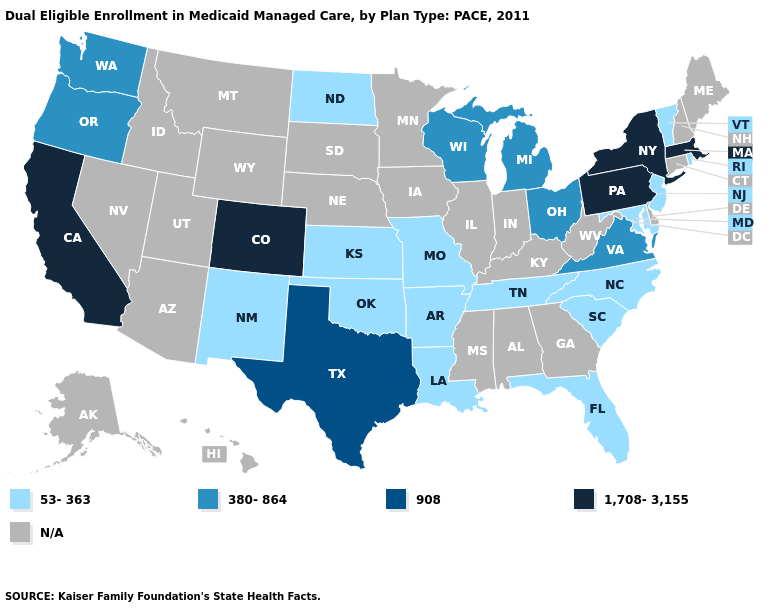Name the states that have a value in the range 908?
Be succinct. Texas. What is the value of Nevada?
Answer briefly. N/A. Name the states that have a value in the range 53-363?
Answer briefly. Arkansas, Florida, Kansas, Louisiana, Maryland, Missouri, New Jersey, New Mexico, North Carolina, North Dakota, Oklahoma, Rhode Island, South Carolina, Tennessee, Vermont. Does New Jersey have the highest value in the Northeast?
Keep it brief. No. What is the value of Michigan?
Concise answer only. 380-864. Which states have the highest value in the USA?
Concise answer only. California, Colorado, Massachusetts, New York, Pennsylvania. Name the states that have a value in the range 380-864?
Concise answer only. Michigan, Ohio, Oregon, Virginia, Washington, Wisconsin. Which states hav the highest value in the MidWest?
Short answer required. Michigan, Ohio, Wisconsin. Among the states that border New York , does New Jersey have the lowest value?
Concise answer only. Yes. What is the highest value in the West ?
Write a very short answer. 1,708-3,155. Among the states that border Pennsylvania , which have the lowest value?
Write a very short answer. Maryland, New Jersey. Name the states that have a value in the range 1,708-3,155?
Write a very short answer. California, Colorado, Massachusetts, New York, Pennsylvania. 